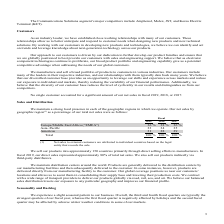According to Te Connectivity's financial document, What are the net sales by geographic region to external customers attributed to? individual countries based on the legal entity that records the sale. The document states: "Net sales to external customers are attributed to individual countries based on the legal entity that records the sale...." Also, What are the net sales by geographic region in the table presented as a percentage of? According to the financial document, total net sales. The relevant text states: "geographic region (1) as a percentage of our total net sales were as follows:..." Also, Which are the geographic regions in which the company operates in? The document contains multiple relevant values: Europe/Middle East/Africa (“EMEA”), Asia–Pacific, Americas. From the document: "Asia–Pacific 33 34 35 Americas 31 28 29 Europe/Middle East/Africa (“EMEA”) 36 % 38 % 36 %..." Additionally, In which year was the percentage in Americas the largest? According to the financial document, 2019. The relevant text states: "2019 2018 2017..." Also, can you calculate: What was the change in percentage in Americas in 2019 from 2018? Based on the calculation: 31-28, the result is 3 (percentage). This is based on the information: "Americas 31 28 29 Americas 31 28 29..." The key data points involved are: 28, 31. Also, can you calculate: What was the average net sales in Asia-Pacific as a percentage of total net sales across 2017, 2018 and 2019? To answer this question, I need to perform calculations using the financial data. The calculation is: (33+34+35)/3, which equals 34 (percentage). This is based on the information: "Asia–Pacific 33 34 35 Asia–Pacific 33 34 35 Asia–Pacific 33 34 35..." The key data points involved are: 33, 35. 